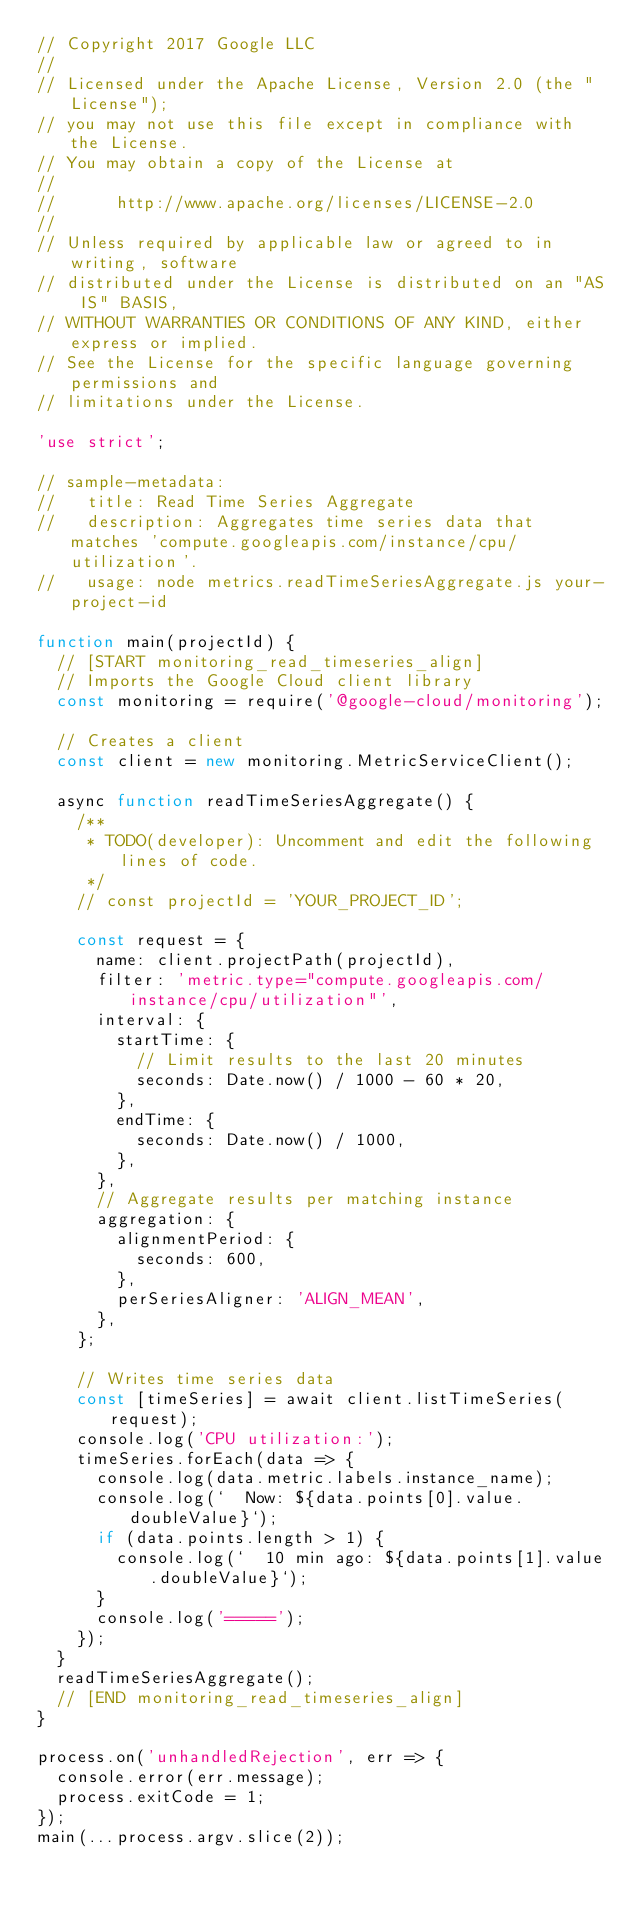<code> <loc_0><loc_0><loc_500><loc_500><_JavaScript_>// Copyright 2017 Google LLC
//
// Licensed under the Apache License, Version 2.0 (the "License");
// you may not use this file except in compliance with the License.
// You may obtain a copy of the License at
//
//      http://www.apache.org/licenses/LICENSE-2.0
//
// Unless required by applicable law or agreed to in writing, software
// distributed under the License is distributed on an "AS IS" BASIS,
// WITHOUT WARRANTIES OR CONDITIONS OF ANY KIND, either express or implied.
// See the License for the specific language governing permissions and
// limitations under the License.

'use strict';

// sample-metadata:
//   title: Read Time Series Aggregate
//   description: Aggregates time series data that matches 'compute.googleapis.com/instance/cpu/utilization'.
//   usage: node metrics.readTimeSeriesAggregate.js your-project-id

function main(projectId) {
  // [START monitoring_read_timeseries_align]
  // Imports the Google Cloud client library
  const monitoring = require('@google-cloud/monitoring');

  // Creates a client
  const client = new monitoring.MetricServiceClient();

  async function readTimeSeriesAggregate() {
    /**
     * TODO(developer): Uncomment and edit the following lines of code.
     */
    // const projectId = 'YOUR_PROJECT_ID';

    const request = {
      name: client.projectPath(projectId),
      filter: 'metric.type="compute.googleapis.com/instance/cpu/utilization"',
      interval: {
        startTime: {
          // Limit results to the last 20 minutes
          seconds: Date.now() / 1000 - 60 * 20,
        },
        endTime: {
          seconds: Date.now() / 1000,
        },
      },
      // Aggregate results per matching instance
      aggregation: {
        alignmentPeriod: {
          seconds: 600,
        },
        perSeriesAligner: 'ALIGN_MEAN',
      },
    };

    // Writes time series data
    const [timeSeries] = await client.listTimeSeries(request);
    console.log('CPU utilization:');
    timeSeries.forEach(data => {
      console.log(data.metric.labels.instance_name);
      console.log(`  Now: ${data.points[0].value.doubleValue}`);
      if (data.points.length > 1) {
        console.log(`  10 min ago: ${data.points[1].value.doubleValue}`);
      }
      console.log('=====');
    });
  }
  readTimeSeriesAggregate();
  // [END monitoring_read_timeseries_align]
}

process.on('unhandledRejection', err => {
  console.error(err.message);
  process.exitCode = 1;
});
main(...process.argv.slice(2));
</code> 